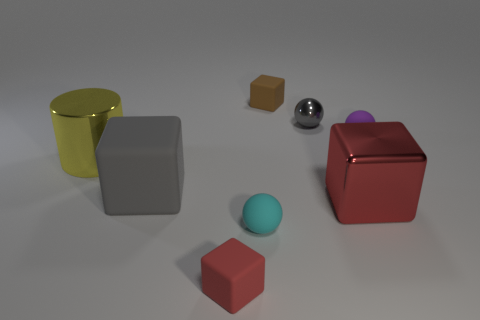Are there any other things that are the same shape as the yellow metal object?
Your answer should be very brief. No. What is the color of the tiny thing that is to the left of the matte sphere in front of the red cube to the right of the red rubber object?
Your answer should be very brief. Red. Are there any things that are in front of the gray thing to the right of the tiny brown object?
Offer a terse response. Yes. There is a tiny rubber object that is on the left side of the cyan sphere; is it the same color as the big metallic object that is in front of the yellow object?
Your answer should be very brief. Yes. What number of blue rubber blocks have the same size as the shiny block?
Your response must be concise. 0. There is a shiny object that is to the left of the brown matte block; is its size the same as the small cyan thing?
Give a very brief answer. No. The big rubber object is what shape?
Ensure brevity in your answer.  Cube. There is a matte block that is the same color as the tiny metallic thing; what is its size?
Provide a short and direct response. Large. Do the gray object that is in front of the metal cylinder and the purple object have the same material?
Ensure brevity in your answer.  Yes. Are there any things that have the same color as the big matte block?
Give a very brief answer. Yes. 